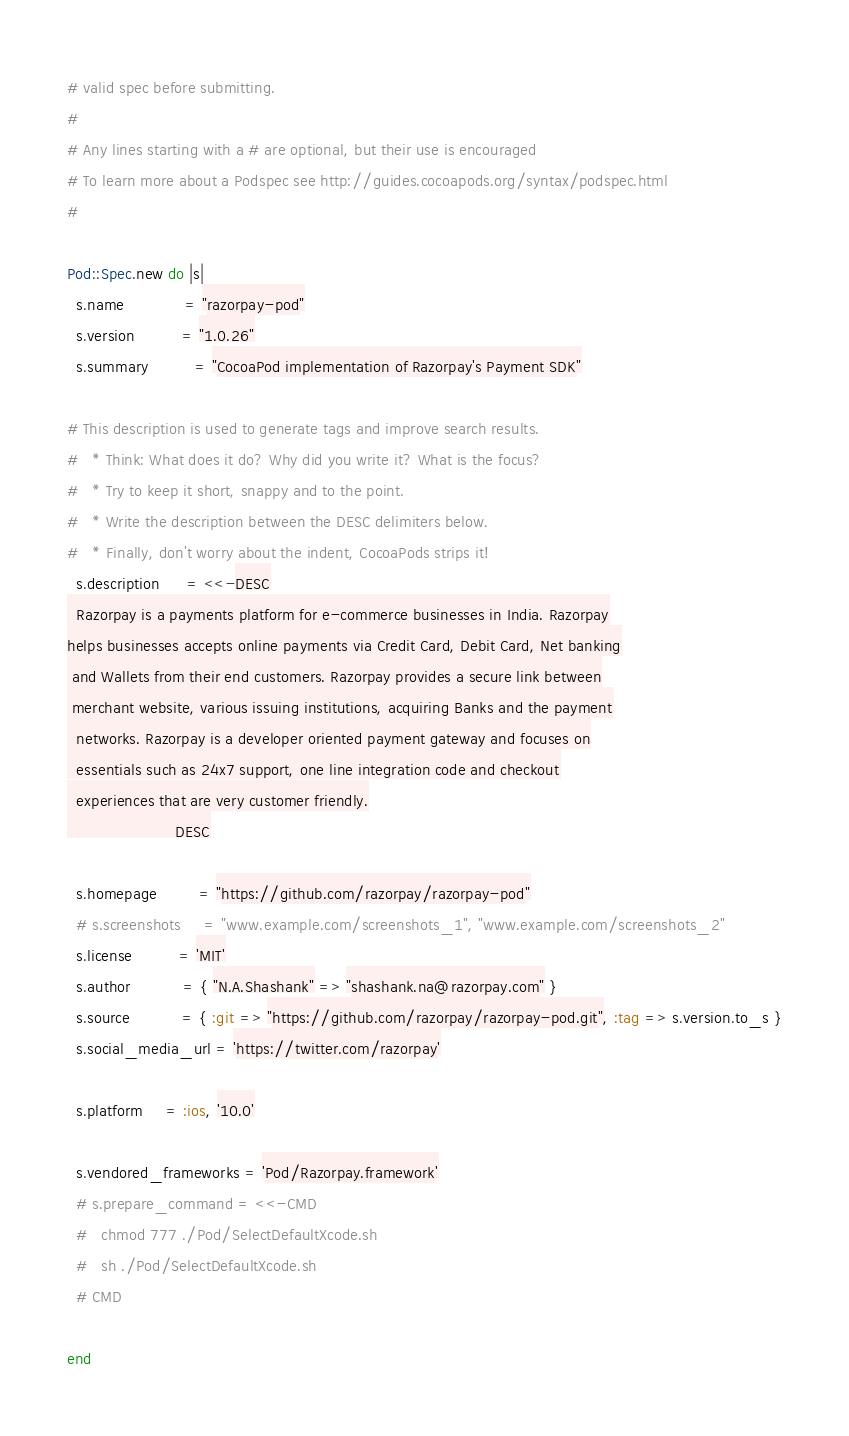Convert code to text. <code><loc_0><loc_0><loc_500><loc_500><_Ruby_># valid spec before submitting.
#
# Any lines starting with a # are optional, but their use is encouraged
# To learn more about a Podspec see http://guides.cocoapods.org/syntax/podspec.html
#

Pod::Spec.new do |s|
  s.name             = "razorpay-pod"
  s.version          = "1.0.26"
  s.summary          = "CocoaPod implementation of Razorpay's Payment SDK"

# This description is used to generate tags and improve search results.
#   * Think: What does it do? Why did you write it? What is the focus?
#   * Try to keep it short, snappy and to the point.
#   * Write the description between the DESC delimiters below.
#   * Finally, don't worry about the indent, CocoaPods strips it!
  s.description      = <<-DESC
  Razorpay is a payments platform for e-commerce businesses in India. Razorpay
helps businesses accepts online payments via Credit Card, Debit Card, Net banking
 and Wallets from their end customers. Razorpay provides a secure link between
 merchant website, various issuing institutions, acquiring Banks and the payment
  networks. Razorpay is a developer oriented payment gateway and focuses on
  essentials such as 24x7 support, one line integration code and checkout
  experiences that are very customer friendly.
                       DESC

  s.homepage         = "https://github.com/razorpay/razorpay-pod"
  # s.screenshots     = "www.example.com/screenshots_1", "www.example.com/screenshots_2"
  s.license          = 'MIT'
  s.author           = { "N.A.Shashank" => "shashank.na@razorpay.com" }
  s.source           = { :git => "https://github.com/razorpay/razorpay-pod.git", :tag => s.version.to_s }
  s.social_media_url = 'https://twitter.com/razorpay'

  s.platform     = :ios, '10.0'
  
  s.vendored_frameworks = 'Pod/Razorpay.framework'
  # s.prepare_command = <<-CMD
  #   chmod 777 ./Pod/SelectDefaultXcode.sh
  #   sh ./Pod/SelectDefaultXcode.sh
  # CMD

end
</code> 